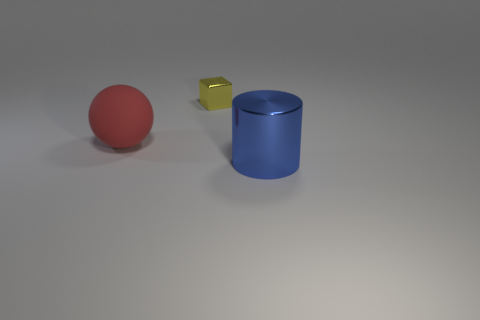Add 3 large shiny cylinders. How many objects exist? 6 Subtract all cubes. How many objects are left? 2 Add 3 tiny yellow blocks. How many tiny yellow blocks exist? 4 Subtract 0 gray cylinders. How many objects are left? 3 Subtract all matte things. Subtract all large red things. How many objects are left? 1 Add 1 yellow shiny things. How many yellow shiny things are left? 2 